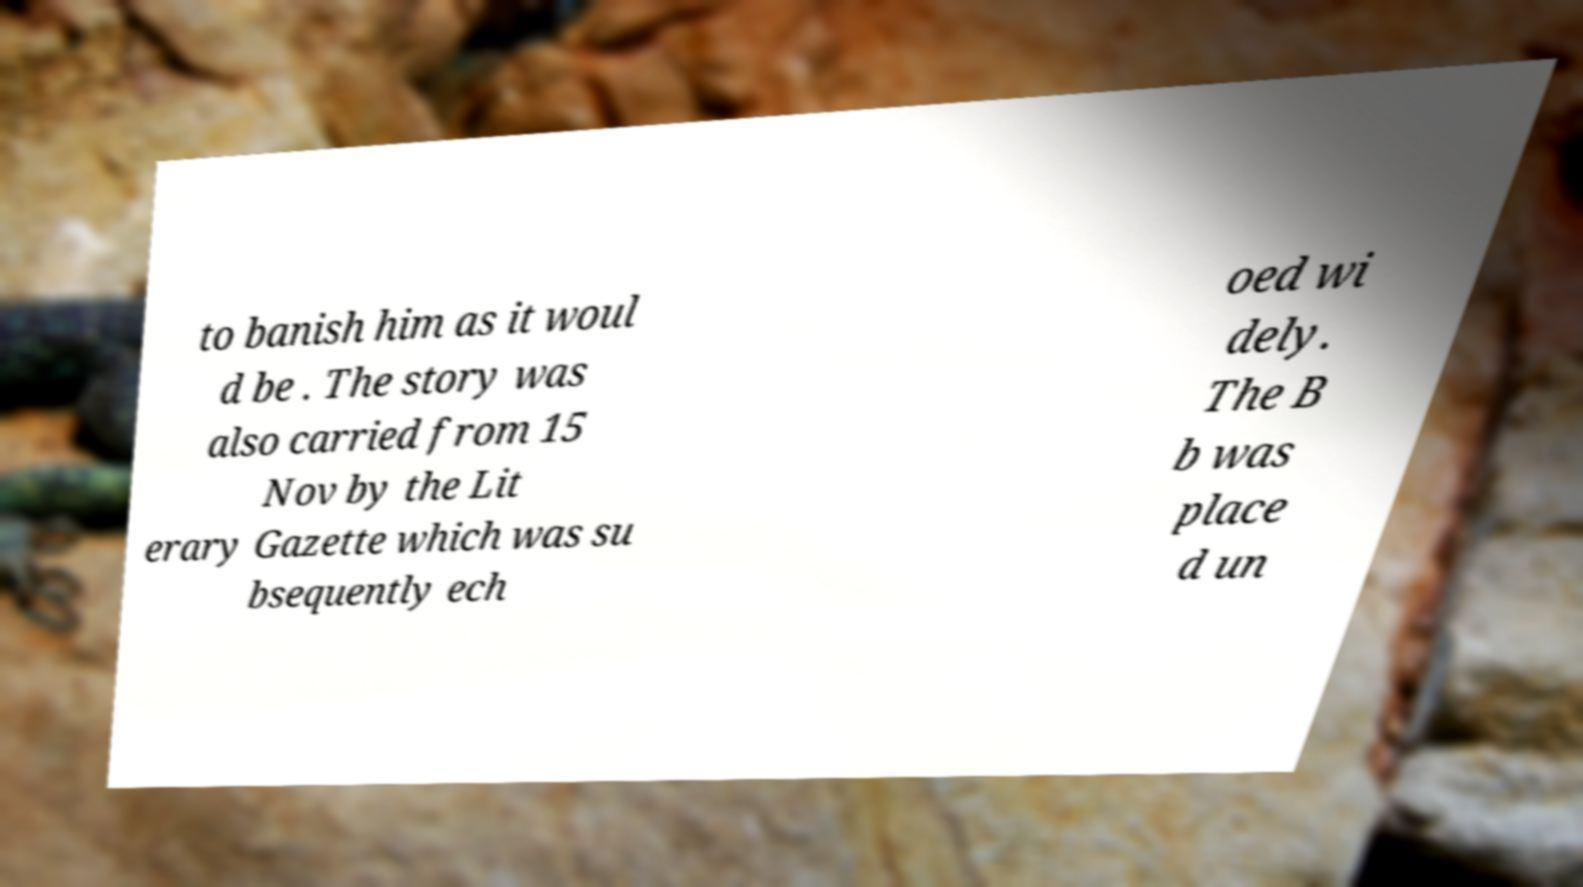Can you accurately transcribe the text from the provided image for me? to banish him as it woul d be . The story was also carried from 15 Nov by the Lit erary Gazette which was su bsequently ech oed wi dely. The B b was place d un 